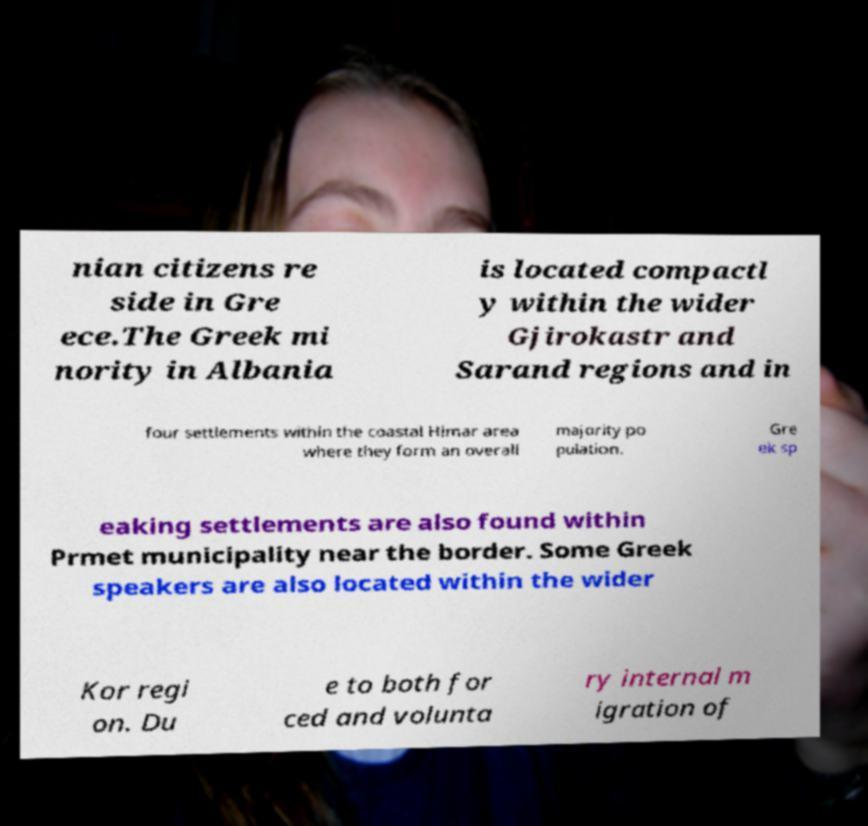I need the written content from this picture converted into text. Can you do that? nian citizens re side in Gre ece.The Greek mi nority in Albania is located compactl y within the wider Gjirokastr and Sarand regions and in four settlements within the coastal Himar area where they form an overall majority po pulation. Gre ek sp eaking settlements are also found within Prmet municipality near the border. Some Greek speakers are also located within the wider Kor regi on. Du e to both for ced and volunta ry internal m igration of 